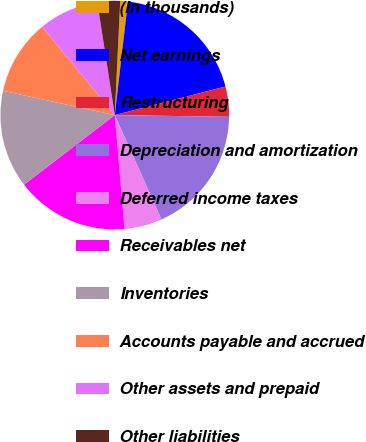<chart> <loc_0><loc_0><loc_500><loc_500><pie_chart><fcel>(In thousands)<fcel>Net earnings<fcel>Restructuring<fcel>Depreciation and amortization<fcel>Deferred income taxes<fcel>Receivables net<fcel>Inventories<fcel>Accounts payable and accrued<fcel>Other assets and prepaid<fcel>Other liabilities<nl><fcel>1.08%<fcel>19.14%<fcel>4.26%<fcel>18.07%<fcel>5.33%<fcel>15.95%<fcel>13.82%<fcel>10.64%<fcel>8.51%<fcel>3.2%<nl></chart> 